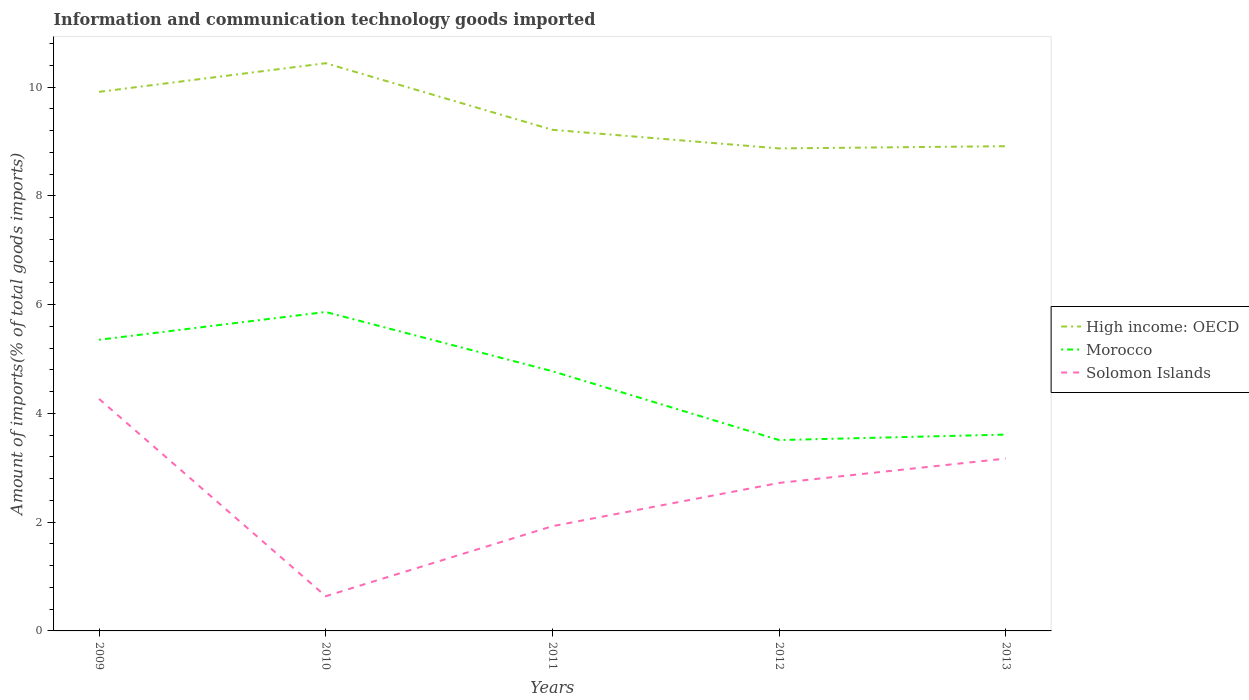Does the line corresponding to Morocco intersect with the line corresponding to Solomon Islands?
Your answer should be very brief. No. Is the number of lines equal to the number of legend labels?
Provide a succinct answer. Yes. Across all years, what is the maximum amount of goods imported in High income: OECD?
Give a very brief answer. 8.87. In which year was the amount of goods imported in High income: OECD maximum?
Keep it short and to the point. 2012. What is the total amount of goods imported in Solomon Islands in the graph?
Keep it short and to the point. 1.55. What is the difference between the highest and the second highest amount of goods imported in Morocco?
Ensure brevity in your answer.  2.36. What is the difference between the highest and the lowest amount of goods imported in Solomon Islands?
Your answer should be compact. 3. Is the amount of goods imported in Solomon Islands strictly greater than the amount of goods imported in Morocco over the years?
Your answer should be very brief. Yes. What is the difference between two consecutive major ticks on the Y-axis?
Provide a short and direct response. 2. Does the graph contain any zero values?
Offer a very short reply. No. Does the graph contain grids?
Provide a succinct answer. No. How are the legend labels stacked?
Your response must be concise. Vertical. What is the title of the graph?
Offer a terse response. Information and communication technology goods imported. What is the label or title of the Y-axis?
Give a very brief answer. Amount of imports(% of total goods imports). What is the Amount of imports(% of total goods imports) in High income: OECD in 2009?
Provide a short and direct response. 9.92. What is the Amount of imports(% of total goods imports) of Morocco in 2009?
Give a very brief answer. 5.36. What is the Amount of imports(% of total goods imports) of Solomon Islands in 2009?
Your answer should be compact. 4.27. What is the Amount of imports(% of total goods imports) of High income: OECD in 2010?
Provide a succinct answer. 10.44. What is the Amount of imports(% of total goods imports) in Morocco in 2010?
Offer a very short reply. 5.87. What is the Amount of imports(% of total goods imports) of Solomon Islands in 2010?
Provide a succinct answer. 0.64. What is the Amount of imports(% of total goods imports) of High income: OECD in 2011?
Provide a succinct answer. 9.22. What is the Amount of imports(% of total goods imports) of Morocco in 2011?
Keep it short and to the point. 4.78. What is the Amount of imports(% of total goods imports) in Solomon Islands in 2011?
Your answer should be very brief. 1.93. What is the Amount of imports(% of total goods imports) in High income: OECD in 2012?
Ensure brevity in your answer.  8.87. What is the Amount of imports(% of total goods imports) in Morocco in 2012?
Make the answer very short. 3.51. What is the Amount of imports(% of total goods imports) in Solomon Islands in 2012?
Make the answer very short. 2.72. What is the Amount of imports(% of total goods imports) in High income: OECD in 2013?
Provide a succinct answer. 8.92. What is the Amount of imports(% of total goods imports) of Morocco in 2013?
Your answer should be compact. 3.61. What is the Amount of imports(% of total goods imports) of Solomon Islands in 2013?
Your answer should be very brief. 3.17. Across all years, what is the maximum Amount of imports(% of total goods imports) of High income: OECD?
Keep it short and to the point. 10.44. Across all years, what is the maximum Amount of imports(% of total goods imports) in Morocco?
Offer a very short reply. 5.87. Across all years, what is the maximum Amount of imports(% of total goods imports) in Solomon Islands?
Make the answer very short. 4.27. Across all years, what is the minimum Amount of imports(% of total goods imports) in High income: OECD?
Ensure brevity in your answer.  8.87. Across all years, what is the minimum Amount of imports(% of total goods imports) in Morocco?
Provide a short and direct response. 3.51. Across all years, what is the minimum Amount of imports(% of total goods imports) of Solomon Islands?
Your answer should be very brief. 0.64. What is the total Amount of imports(% of total goods imports) in High income: OECD in the graph?
Keep it short and to the point. 47.36. What is the total Amount of imports(% of total goods imports) in Morocco in the graph?
Offer a very short reply. 23.12. What is the total Amount of imports(% of total goods imports) in Solomon Islands in the graph?
Provide a succinct answer. 12.73. What is the difference between the Amount of imports(% of total goods imports) of High income: OECD in 2009 and that in 2010?
Your response must be concise. -0.53. What is the difference between the Amount of imports(% of total goods imports) in Morocco in 2009 and that in 2010?
Your response must be concise. -0.51. What is the difference between the Amount of imports(% of total goods imports) of Solomon Islands in 2009 and that in 2010?
Keep it short and to the point. 3.63. What is the difference between the Amount of imports(% of total goods imports) of High income: OECD in 2009 and that in 2011?
Your answer should be very brief. 0.7. What is the difference between the Amount of imports(% of total goods imports) in Morocco in 2009 and that in 2011?
Offer a very short reply. 0.58. What is the difference between the Amount of imports(% of total goods imports) in Solomon Islands in 2009 and that in 2011?
Your response must be concise. 2.34. What is the difference between the Amount of imports(% of total goods imports) in High income: OECD in 2009 and that in 2012?
Your answer should be compact. 1.04. What is the difference between the Amount of imports(% of total goods imports) in Morocco in 2009 and that in 2012?
Your response must be concise. 1.84. What is the difference between the Amount of imports(% of total goods imports) in Solomon Islands in 2009 and that in 2012?
Keep it short and to the point. 1.55. What is the difference between the Amount of imports(% of total goods imports) in Morocco in 2009 and that in 2013?
Your response must be concise. 1.74. What is the difference between the Amount of imports(% of total goods imports) of Solomon Islands in 2009 and that in 2013?
Keep it short and to the point. 1.1. What is the difference between the Amount of imports(% of total goods imports) in High income: OECD in 2010 and that in 2011?
Offer a terse response. 1.22. What is the difference between the Amount of imports(% of total goods imports) in Morocco in 2010 and that in 2011?
Ensure brevity in your answer.  1.09. What is the difference between the Amount of imports(% of total goods imports) in Solomon Islands in 2010 and that in 2011?
Provide a succinct answer. -1.29. What is the difference between the Amount of imports(% of total goods imports) in High income: OECD in 2010 and that in 2012?
Your answer should be very brief. 1.57. What is the difference between the Amount of imports(% of total goods imports) of Morocco in 2010 and that in 2012?
Offer a very short reply. 2.36. What is the difference between the Amount of imports(% of total goods imports) in Solomon Islands in 2010 and that in 2012?
Offer a very short reply. -2.08. What is the difference between the Amount of imports(% of total goods imports) in High income: OECD in 2010 and that in 2013?
Your response must be concise. 1.53. What is the difference between the Amount of imports(% of total goods imports) of Morocco in 2010 and that in 2013?
Provide a succinct answer. 2.26. What is the difference between the Amount of imports(% of total goods imports) of Solomon Islands in 2010 and that in 2013?
Provide a succinct answer. -2.53. What is the difference between the Amount of imports(% of total goods imports) in High income: OECD in 2011 and that in 2012?
Your response must be concise. 0.34. What is the difference between the Amount of imports(% of total goods imports) in Morocco in 2011 and that in 2012?
Keep it short and to the point. 1.27. What is the difference between the Amount of imports(% of total goods imports) in Solomon Islands in 2011 and that in 2012?
Your answer should be compact. -0.8. What is the difference between the Amount of imports(% of total goods imports) of High income: OECD in 2011 and that in 2013?
Offer a terse response. 0.3. What is the difference between the Amount of imports(% of total goods imports) in Morocco in 2011 and that in 2013?
Keep it short and to the point. 1.17. What is the difference between the Amount of imports(% of total goods imports) of Solomon Islands in 2011 and that in 2013?
Provide a short and direct response. -1.24. What is the difference between the Amount of imports(% of total goods imports) of High income: OECD in 2012 and that in 2013?
Provide a short and direct response. -0.04. What is the difference between the Amount of imports(% of total goods imports) of Morocco in 2012 and that in 2013?
Your answer should be very brief. -0.1. What is the difference between the Amount of imports(% of total goods imports) in Solomon Islands in 2012 and that in 2013?
Your answer should be very brief. -0.45. What is the difference between the Amount of imports(% of total goods imports) in High income: OECD in 2009 and the Amount of imports(% of total goods imports) in Morocco in 2010?
Your answer should be compact. 4.05. What is the difference between the Amount of imports(% of total goods imports) of High income: OECD in 2009 and the Amount of imports(% of total goods imports) of Solomon Islands in 2010?
Provide a succinct answer. 9.28. What is the difference between the Amount of imports(% of total goods imports) of Morocco in 2009 and the Amount of imports(% of total goods imports) of Solomon Islands in 2010?
Your answer should be compact. 4.72. What is the difference between the Amount of imports(% of total goods imports) in High income: OECD in 2009 and the Amount of imports(% of total goods imports) in Morocco in 2011?
Offer a terse response. 5.14. What is the difference between the Amount of imports(% of total goods imports) of High income: OECD in 2009 and the Amount of imports(% of total goods imports) of Solomon Islands in 2011?
Ensure brevity in your answer.  7.99. What is the difference between the Amount of imports(% of total goods imports) in Morocco in 2009 and the Amount of imports(% of total goods imports) in Solomon Islands in 2011?
Ensure brevity in your answer.  3.43. What is the difference between the Amount of imports(% of total goods imports) of High income: OECD in 2009 and the Amount of imports(% of total goods imports) of Morocco in 2012?
Ensure brevity in your answer.  6.4. What is the difference between the Amount of imports(% of total goods imports) of High income: OECD in 2009 and the Amount of imports(% of total goods imports) of Solomon Islands in 2012?
Provide a short and direct response. 7.19. What is the difference between the Amount of imports(% of total goods imports) of Morocco in 2009 and the Amount of imports(% of total goods imports) of Solomon Islands in 2012?
Offer a terse response. 2.63. What is the difference between the Amount of imports(% of total goods imports) in High income: OECD in 2009 and the Amount of imports(% of total goods imports) in Morocco in 2013?
Your answer should be compact. 6.3. What is the difference between the Amount of imports(% of total goods imports) in High income: OECD in 2009 and the Amount of imports(% of total goods imports) in Solomon Islands in 2013?
Make the answer very short. 6.74. What is the difference between the Amount of imports(% of total goods imports) of Morocco in 2009 and the Amount of imports(% of total goods imports) of Solomon Islands in 2013?
Provide a succinct answer. 2.18. What is the difference between the Amount of imports(% of total goods imports) of High income: OECD in 2010 and the Amount of imports(% of total goods imports) of Morocco in 2011?
Provide a short and direct response. 5.67. What is the difference between the Amount of imports(% of total goods imports) in High income: OECD in 2010 and the Amount of imports(% of total goods imports) in Solomon Islands in 2011?
Give a very brief answer. 8.52. What is the difference between the Amount of imports(% of total goods imports) of Morocco in 2010 and the Amount of imports(% of total goods imports) of Solomon Islands in 2011?
Ensure brevity in your answer.  3.94. What is the difference between the Amount of imports(% of total goods imports) of High income: OECD in 2010 and the Amount of imports(% of total goods imports) of Morocco in 2012?
Your answer should be compact. 6.93. What is the difference between the Amount of imports(% of total goods imports) in High income: OECD in 2010 and the Amount of imports(% of total goods imports) in Solomon Islands in 2012?
Offer a terse response. 7.72. What is the difference between the Amount of imports(% of total goods imports) of Morocco in 2010 and the Amount of imports(% of total goods imports) of Solomon Islands in 2012?
Give a very brief answer. 3.14. What is the difference between the Amount of imports(% of total goods imports) of High income: OECD in 2010 and the Amount of imports(% of total goods imports) of Morocco in 2013?
Your answer should be compact. 6.83. What is the difference between the Amount of imports(% of total goods imports) of High income: OECD in 2010 and the Amount of imports(% of total goods imports) of Solomon Islands in 2013?
Your answer should be compact. 7.27. What is the difference between the Amount of imports(% of total goods imports) in Morocco in 2010 and the Amount of imports(% of total goods imports) in Solomon Islands in 2013?
Your response must be concise. 2.7. What is the difference between the Amount of imports(% of total goods imports) in High income: OECD in 2011 and the Amount of imports(% of total goods imports) in Morocco in 2012?
Give a very brief answer. 5.71. What is the difference between the Amount of imports(% of total goods imports) of High income: OECD in 2011 and the Amount of imports(% of total goods imports) of Solomon Islands in 2012?
Your answer should be compact. 6.49. What is the difference between the Amount of imports(% of total goods imports) of Morocco in 2011 and the Amount of imports(% of total goods imports) of Solomon Islands in 2012?
Provide a succinct answer. 2.05. What is the difference between the Amount of imports(% of total goods imports) of High income: OECD in 2011 and the Amount of imports(% of total goods imports) of Morocco in 2013?
Make the answer very short. 5.61. What is the difference between the Amount of imports(% of total goods imports) of High income: OECD in 2011 and the Amount of imports(% of total goods imports) of Solomon Islands in 2013?
Your answer should be compact. 6.05. What is the difference between the Amount of imports(% of total goods imports) in Morocco in 2011 and the Amount of imports(% of total goods imports) in Solomon Islands in 2013?
Make the answer very short. 1.61. What is the difference between the Amount of imports(% of total goods imports) in High income: OECD in 2012 and the Amount of imports(% of total goods imports) in Morocco in 2013?
Your answer should be very brief. 5.26. What is the difference between the Amount of imports(% of total goods imports) in High income: OECD in 2012 and the Amount of imports(% of total goods imports) in Solomon Islands in 2013?
Keep it short and to the point. 5.7. What is the difference between the Amount of imports(% of total goods imports) of Morocco in 2012 and the Amount of imports(% of total goods imports) of Solomon Islands in 2013?
Give a very brief answer. 0.34. What is the average Amount of imports(% of total goods imports) in High income: OECD per year?
Your response must be concise. 9.47. What is the average Amount of imports(% of total goods imports) of Morocco per year?
Offer a very short reply. 4.62. What is the average Amount of imports(% of total goods imports) in Solomon Islands per year?
Your answer should be compact. 2.55. In the year 2009, what is the difference between the Amount of imports(% of total goods imports) in High income: OECD and Amount of imports(% of total goods imports) in Morocco?
Provide a short and direct response. 4.56. In the year 2009, what is the difference between the Amount of imports(% of total goods imports) of High income: OECD and Amount of imports(% of total goods imports) of Solomon Islands?
Keep it short and to the point. 5.65. In the year 2009, what is the difference between the Amount of imports(% of total goods imports) of Morocco and Amount of imports(% of total goods imports) of Solomon Islands?
Provide a short and direct response. 1.09. In the year 2010, what is the difference between the Amount of imports(% of total goods imports) of High income: OECD and Amount of imports(% of total goods imports) of Morocco?
Keep it short and to the point. 4.58. In the year 2010, what is the difference between the Amount of imports(% of total goods imports) of High income: OECD and Amount of imports(% of total goods imports) of Solomon Islands?
Your answer should be compact. 9.8. In the year 2010, what is the difference between the Amount of imports(% of total goods imports) in Morocco and Amount of imports(% of total goods imports) in Solomon Islands?
Give a very brief answer. 5.23. In the year 2011, what is the difference between the Amount of imports(% of total goods imports) of High income: OECD and Amount of imports(% of total goods imports) of Morocco?
Offer a terse response. 4.44. In the year 2011, what is the difference between the Amount of imports(% of total goods imports) in High income: OECD and Amount of imports(% of total goods imports) in Solomon Islands?
Provide a short and direct response. 7.29. In the year 2011, what is the difference between the Amount of imports(% of total goods imports) in Morocco and Amount of imports(% of total goods imports) in Solomon Islands?
Give a very brief answer. 2.85. In the year 2012, what is the difference between the Amount of imports(% of total goods imports) in High income: OECD and Amount of imports(% of total goods imports) in Morocco?
Your answer should be very brief. 5.36. In the year 2012, what is the difference between the Amount of imports(% of total goods imports) in High income: OECD and Amount of imports(% of total goods imports) in Solomon Islands?
Provide a short and direct response. 6.15. In the year 2012, what is the difference between the Amount of imports(% of total goods imports) in Morocco and Amount of imports(% of total goods imports) in Solomon Islands?
Keep it short and to the point. 0.79. In the year 2013, what is the difference between the Amount of imports(% of total goods imports) in High income: OECD and Amount of imports(% of total goods imports) in Morocco?
Give a very brief answer. 5.3. In the year 2013, what is the difference between the Amount of imports(% of total goods imports) of High income: OECD and Amount of imports(% of total goods imports) of Solomon Islands?
Keep it short and to the point. 5.75. In the year 2013, what is the difference between the Amount of imports(% of total goods imports) of Morocco and Amount of imports(% of total goods imports) of Solomon Islands?
Your answer should be compact. 0.44. What is the ratio of the Amount of imports(% of total goods imports) in High income: OECD in 2009 to that in 2010?
Your answer should be compact. 0.95. What is the ratio of the Amount of imports(% of total goods imports) in Morocco in 2009 to that in 2010?
Provide a succinct answer. 0.91. What is the ratio of the Amount of imports(% of total goods imports) in Solomon Islands in 2009 to that in 2010?
Provide a short and direct response. 6.68. What is the ratio of the Amount of imports(% of total goods imports) in High income: OECD in 2009 to that in 2011?
Offer a very short reply. 1.08. What is the ratio of the Amount of imports(% of total goods imports) in Morocco in 2009 to that in 2011?
Keep it short and to the point. 1.12. What is the ratio of the Amount of imports(% of total goods imports) of Solomon Islands in 2009 to that in 2011?
Give a very brief answer. 2.22. What is the ratio of the Amount of imports(% of total goods imports) in High income: OECD in 2009 to that in 2012?
Your response must be concise. 1.12. What is the ratio of the Amount of imports(% of total goods imports) of Morocco in 2009 to that in 2012?
Ensure brevity in your answer.  1.53. What is the ratio of the Amount of imports(% of total goods imports) in Solomon Islands in 2009 to that in 2012?
Provide a succinct answer. 1.57. What is the ratio of the Amount of imports(% of total goods imports) in High income: OECD in 2009 to that in 2013?
Provide a succinct answer. 1.11. What is the ratio of the Amount of imports(% of total goods imports) of Morocco in 2009 to that in 2013?
Your answer should be compact. 1.48. What is the ratio of the Amount of imports(% of total goods imports) of Solomon Islands in 2009 to that in 2013?
Make the answer very short. 1.35. What is the ratio of the Amount of imports(% of total goods imports) of High income: OECD in 2010 to that in 2011?
Offer a very short reply. 1.13. What is the ratio of the Amount of imports(% of total goods imports) in Morocco in 2010 to that in 2011?
Give a very brief answer. 1.23. What is the ratio of the Amount of imports(% of total goods imports) of Solomon Islands in 2010 to that in 2011?
Ensure brevity in your answer.  0.33. What is the ratio of the Amount of imports(% of total goods imports) of High income: OECD in 2010 to that in 2012?
Offer a very short reply. 1.18. What is the ratio of the Amount of imports(% of total goods imports) of Morocco in 2010 to that in 2012?
Give a very brief answer. 1.67. What is the ratio of the Amount of imports(% of total goods imports) in Solomon Islands in 2010 to that in 2012?
Your response must be concise. 0.23. What is the ratio of the Amount of imports(% of total goods imports) of High income: OECD in 2010 to that in 2013?
Provide a succinct answer. 1.17. What is the ratio of the Amount of imports(% of total goods imports) of Morocco in 2010 to that in 2013?
Ensure brevity in your answer.  1.62. What is the ratio of the Amount of imports(% of total goods imports) in Solomon Islands in 2010 to that in 2013?
Offer a very short reply. 0.2. What is the ratio of the Amount of imports(% of total goods imports) of High income: OECD in 2011 to that in 2012?
Ensure brevity in your answer.  1.04. What is the ratio of the Amount of imports(% of total goods imports) in Morocco in 2011 to that in 2012?
Provide a succinct answer. 1.36. What is the ratio of the Amount of imports(% of total goods imports) in Solomon Islands in 2011 to that in 2012?
Your response must be concise. 0.71. What is the ratio of the Amount of imports(% of total goods imports) of High income: OECD in 2011 to that in 2013?
Your answer should be very brief. 1.03. What is the ratio of the Amount of imports(% of total goods imports) in Morocco in 2011 to that in 2013?
Your answer should be compact. 1.32. What is the ratio of the Amount of imports(% of total goods imports) in Solomon Islands in 2011 to that in 2013?
Offer a very short reply. 0.61. What is the ratio of the Amount of imports(% of total goods imports) in High income: OECD in 2012 to that in 2013?
Provide a succinct answer. 1. What is the ratio of the Amount of imports(% of total goods imports) of Morocco in 2012 to that in 2013?
Your answer should be compact. 0.97. What is the ratio of the Amount of imports(% of total goods imports) of Solomon Islands in 2012 to that in 2013?
Your answer should be very brief. 0.86. What is the difference between the highest and the second highest Amount of imports(% of total goods imports) of High income: OECD?
Keep it short and to the point. 0.53. What is the difference between the highest and the second highest Amount of imports(% of total goods imports) of Morocco?
Your answer should be very brief. 0.51. What is the difference between the highest and the second highest Amount of imports(% of total goods imports) of Solomon Islands?
Keep it short and to the point. 1.1. What is the difference between the highest and the lowest Amount of imports(% of total goods imports) in High income: OECD?
Your answer should be compact. 1.57. What is the difference between the highest and the lowest Amount of imports(% of total goods imports) of Morocco?
Offer a very short reply. 2.36. What is the difference between the highest and the lowest Amount of imports(% of total goods imports) of Solomon Islands?
Keep it short and to the point. 3.63. 